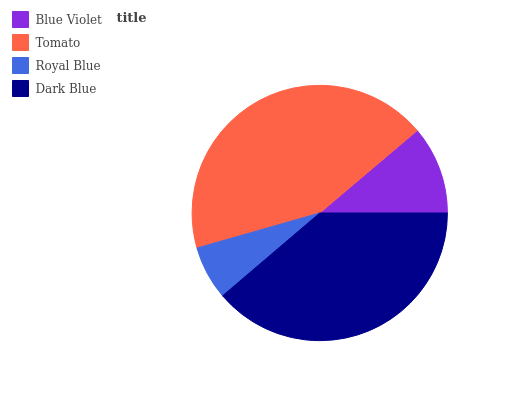Is Royal Blue the minimum?
Answer yes or no. Yes. Is Tomato the maximum?
Answer yes or no. Yes. Is Tomato the minimum?
Answer yes or no. No. Is Royal Blue the maximum?
Answer yes or no. No. Is Tomato greater than Royal Blue?
Answer yes or no. Yes. Is Royal Blue less than Tomato?
Answer yes or no. Yes. Is Royal Blue greater than Tomato?
Answer yes or no. No. Is Tomato less than Royal Blue?
Answer yes or no. No. Is Dark Blue the high median?
Answer yes or no. Yes. Is Blue Violet the low median?
Answer yes or no. Yes. Is Blue Violet the high median?
Answer yes or no. No. Is Dark Blue the low median?
Answer yes or no. No. 